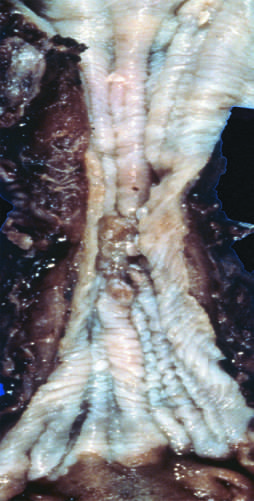where is squamous cell carcinoma found?
Answer the question using a single word or phrase. In the mid-esophagus 